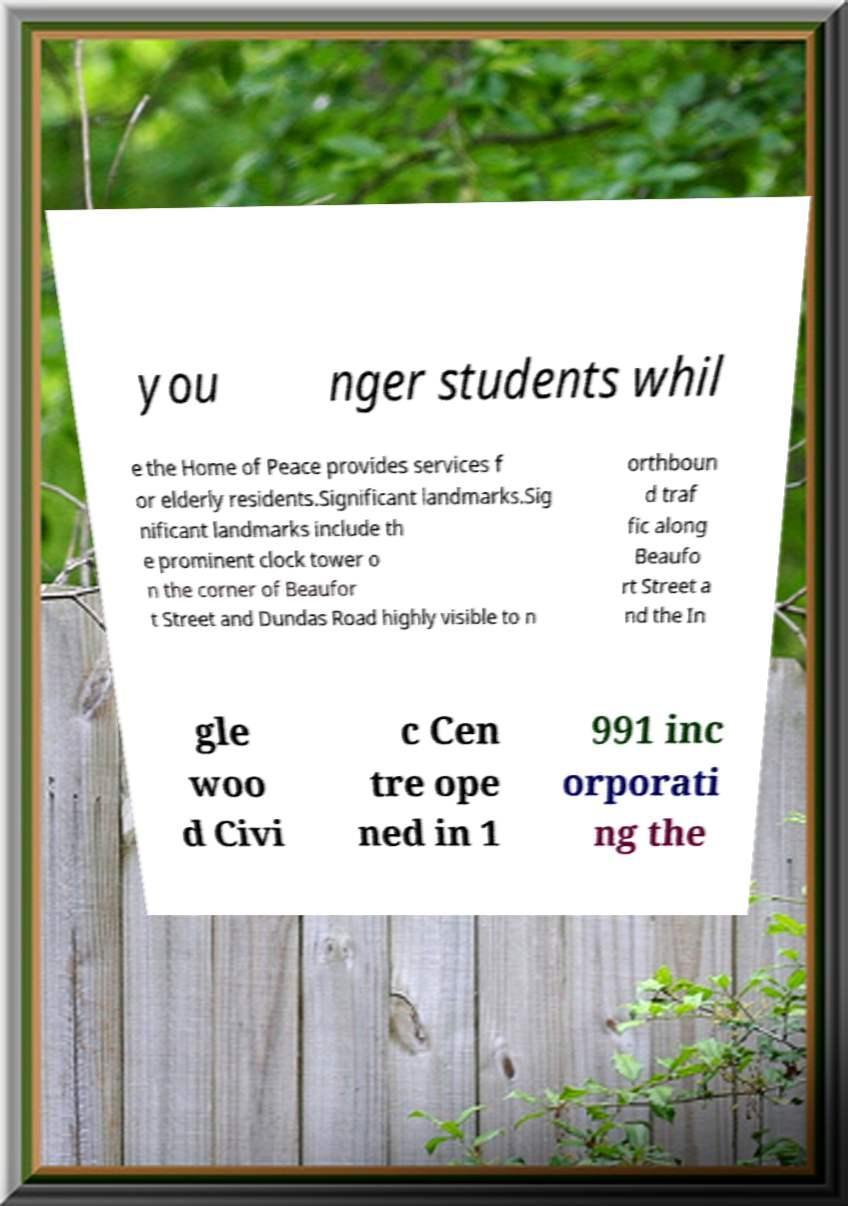Please identify and transcribe the text found in this image. you nger students whil e the Home of Peace provides services f or elderly residents.Significant landmarks.Sig nificant landmarks include th e prominent clock tower o n the corner of Beaufor t Street and Dundas Road highly visible to n orthboun d traf fic along Beaufo rt Street a nd the In gle woo d Civi c Cen tre ope ned in 1 991 inc orporati ng the 